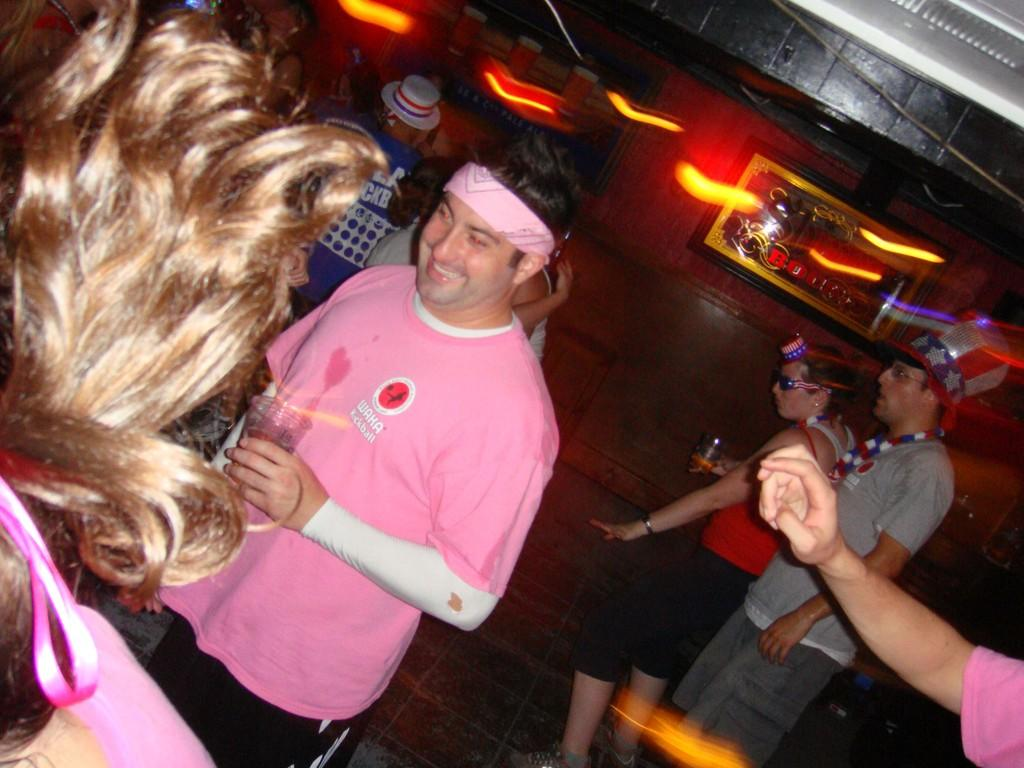How many people are visible in the image? There are people standing in the image. What surface are the people standing on? The people are standing on the floor. What can be seen in the background of the image? There is a wall with frames, the ceiling, and lights visible in the background. Can you describe the right side of the image? The right side of the image shows the hand of a person. What type of stick is being used by the people in the image? There is no stick visible in the image; the people are simply standing. Is there a veil covering any part of the image? No, there is no veil present in the image. 